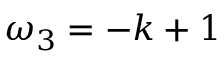Convert formula to latex. <formula><loc_0><loc_0><loc_500><loc_500>\omega _ { 3 } = - k + 1</formula> 